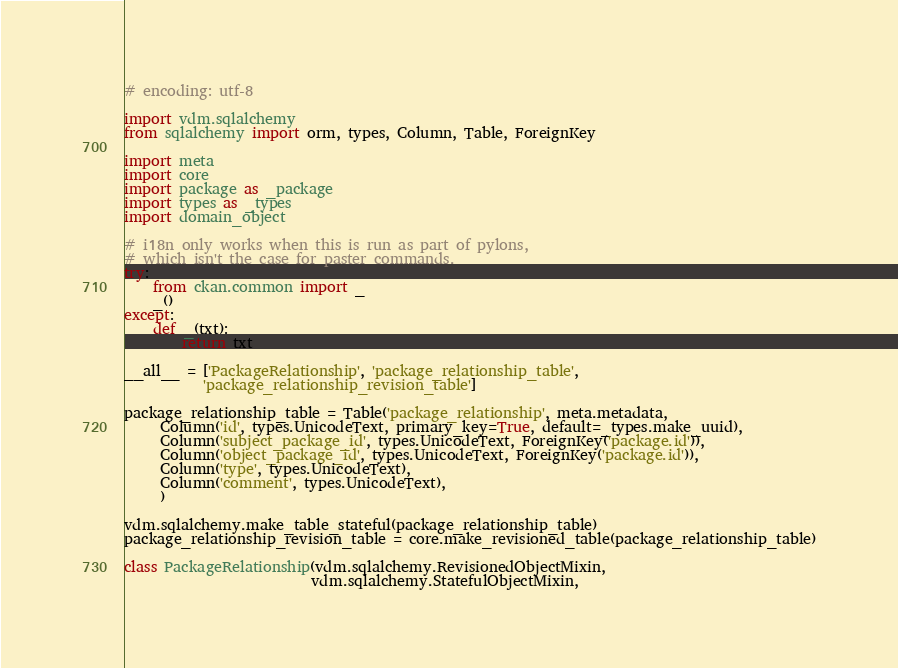Convert code to text. <code><loc_0><loc_0><loc_500><loc_500><_Python_># encoding: utf-8

import vdm.sqlalchemy
from sqlalchemy import orm, types, Column, Table, ForeignKey

import meta
import core
import package as _package
import types as _types
import domain_object

# i18n only works when this is run as part of pylons,
# which isn't the case for paster commands.
try:
    from ckan.common import _
    _()
except:
    def _(txt):
        return txt

__all__ = ['PackageRelationship', 'package_relationship_table',
           'package_relationship_revision_table']

package_relationship_table = Table('package_relationship', meta.metadata,
     Column('id', types.UnicodeText, primary_key=True, default=_types.make_uuid),
     Column('subject_package_id', types.UnicodeText, ForeignKey('package.id')),
     Column('object_package_id', types.UnicodeText, ForeignKey('package.id')),
     Column('type', types.UnicodeText),
     Column('comment', types.UnicodeText),
     )

vdm.sqlalchemy.make_table_stateful(package_relationship_table)
package_relationship_revision_table = core.make_revisioned_table(package_relationship_table)

class PackageRelationship(vdm.sqlalchemy.RevisionedObjectMixin,
                          vdm.sqlalchemy.StatefulObjectMixin,</code> 